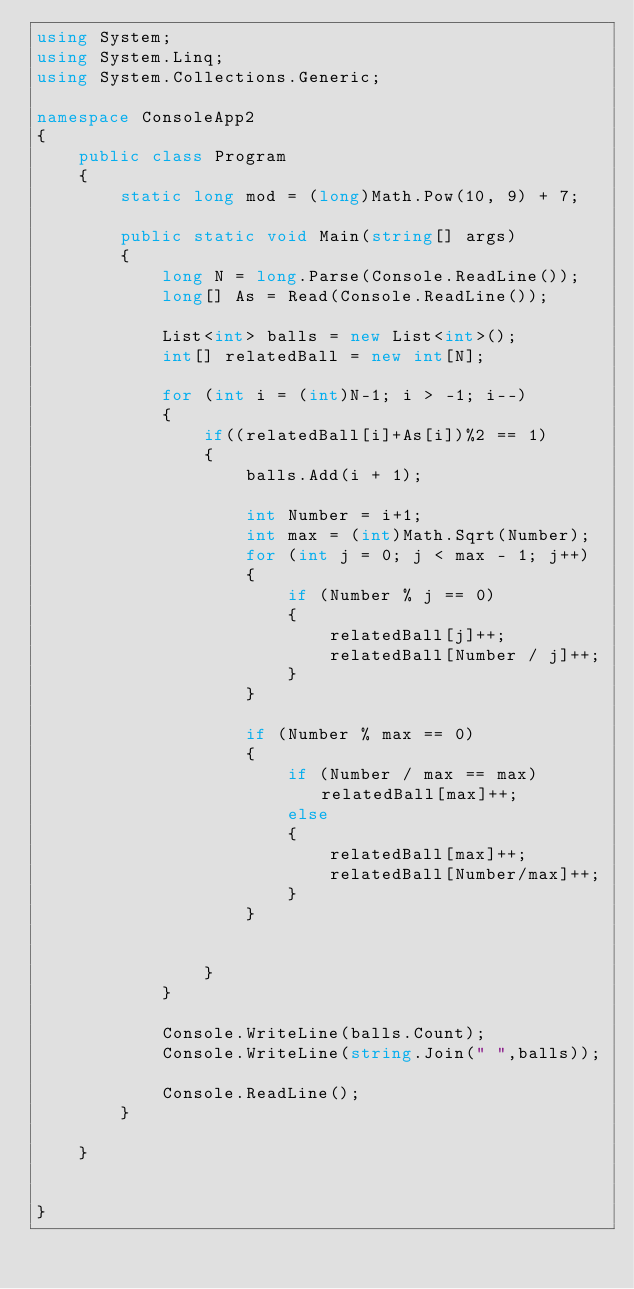Convert code to text. <code><loc_0><loc_0><loc_500><loc_500><_C#_>using System;
using System.Linq;
using System.Collections.Generic;

namespace ConsoleApp2
{
    public class Program
    {
        static long mod = (long)Math.Pow(10, 9) + 7;

        public static void Main(string[] args)
        {
            long N = long.Parse(Console.ReadLine());
            long[] As = Read(Console.ReadLine());

            List<int> balls = new List<int>();
            int[] relatedBall = new int[N];

            for (int i = (int)N-1; i > -1; i--)
            {
                if((relatedBall[i]+As[i])%2 == 1)
                {
                    balls.Add(i + 1);

                    int Number = i+1;
                    int max = (int)Math.Sqrt(Number);
                    for (int j = 0; j < max - 1; j++)
                    {
                        if (Number % j == 0)
                        {
                            relatedBall[j]++;
                            relatedBall[Number / j]++;
                        }
                    }

                    if (Number % max == 0)
                    {
                        if (Number / max == max) relatedBall[max]++;
                        else
                        {
                            relatedBall[max]++;
                            relatedBall[Number/max]++;
                        }
                    }


                }
            }

            Console.WriteLine(balls.Count);
            Console.WriteLine(string.Join(" ",balls));

            Console.ReadLine();
        }
      
    }


}
</code> 